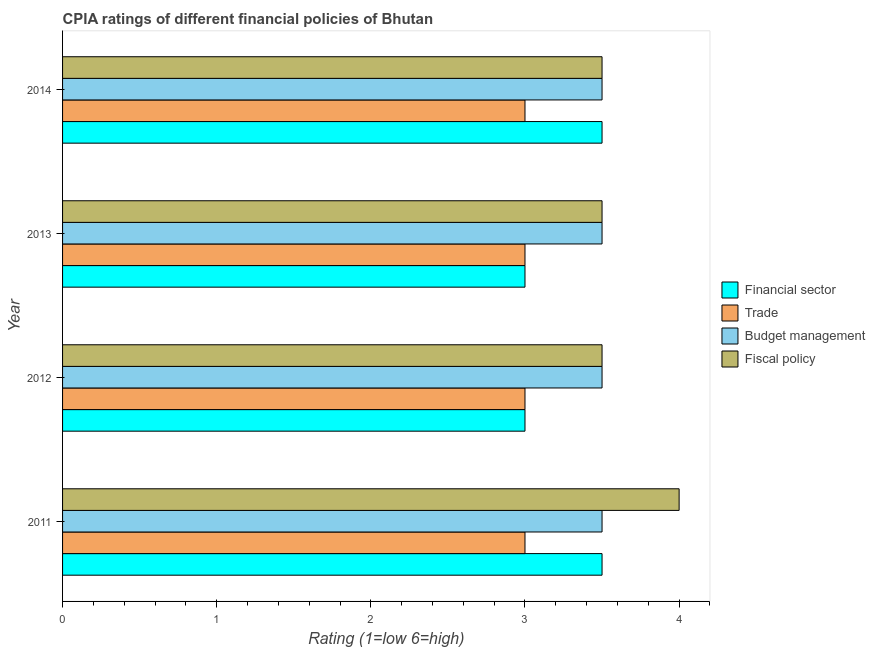How many different coloured bars are there?
Keep it short and to the point. 4. Are the number of bars per tick equal to the number of legend labels?
Your response must be concise. Yes. Are the number of bars on each tick of the Y-axis equal?
Offer a very short reply. Yes. How many bars are there on the 4th tick from the top?
Your answer should be compact. 4. In how many cases, is the number of bars for a given year not equal to the number of legend labels?
Your response must be concise. 0. What is the cpia rating of financial sector in 2012?
Your response must be concise. 3. Across all years, what is the maximum cpia rating of trade?
Provide a short and direct response. 3. Across all years, what is the minimum cpia rating of budget management?
Keep it short and to the point. 3.5. What is the total cpia rating of trade in the graph?
Your answer should be very brief. 12. What is the difference between the cpia rating of trade in 2011 and that in 2012?
Offer a very short reply. 0. What is the average cpia rating of trade per year?
Offer a very short reply. 3. What is the ratio of the cpia rating of financial sector in 2011 to that in 2012?
Offer a terse response. 1.17. What is the difference between the highest and the second highest cpia rating of financial sector?
Your response must be concise. 0. In how many years, is the cpia rating of trade greater than the average cpia rating of trade taken over all years?
Give a very brief answer. 0. Is the sum of the cpia rating of financial sector in 2011 and 2012 greater than the maximum cpia rating of fiscal policy across all years?
Provide a succinct answer. Yes. Is it the case that in every year, the sum of the cpia rating of financial sector and cpia rating of trade is greater than the sum of cpia rating of fiscal policy and cpia rating of budget management?
Give a very brief answer. No. What does the 2nd bar from the top in 2013 represents?
Your answer should be compact. Budget management. What does the 4th bar from the bottom in 2013 represents?
Ensure brevity in your answer.  Fiscal policy. How many bars are there?
Your answer should be very brief. 16. Are all the bars in the graph horizontal?
Provide a succinct answer. Yes. What is the difference between two consecutive major ticks on the X-axis?
Offer a very short reply. 1. Does the graph contain grids?
Offer a very short reply. No. Where does the legend appear in the graph?
Your answer should be compact. Center right. How many legend labels are there?
Provide a short and direct response. 4. What is the title of the graph?
Keep it short and to the point. CPIA ratings of different financial policies of Bhutan. What is the label or title of the Y-axis?
Your response must be concise. Year. What is the Rating (1=low 6=high) of Financial sector in 2011?
Give a very brief answer. 3.5. What is the Rating (1=low 6=high) in Trade in 2012?
Ensure brevity in your answer.  3. What is the Rating (1=low 6=high) of Fiscal policy in 2012?
Your answer should be very brief. 3.5. What is the Rating (1=low 6=high) of Financial sector in 2013?
Offer a terse response. 3. What is the Rating (1=low 6=high) in Trade in 2013?
Ensure brevity in your answer.  3. What is the Rating (1=low 6=high) in Fiscal policy in 2013?
Give a very brief answer. 3.5. What is the Rating (1=low 6=high) of Financial sector in 2014?
Your answer should be very brief. 3.5. What is the Rating (1=low 6=high) of Trade in 2014?
Ensure brevity in your answer.  3. What is the Rating (1=low 6=high) in Budget management in 2014?
Your answer should be compact. 3.5. What is the Rating (1=low 6=high) in Fiscal policy in 2014?
Keep it short and to the point. 3.5. Across all years, what is the maximum Rating (1=low 6=high) of Fiscal policy?
Offer a terse response. 4. What is the total Rating (1=low 6=high) in Financial sector in the graph?
Offer a terse response. 13. What is the total Rating (1=low 6=high) in Budget management in the graph?
Your answer should be very brief. 14. What is the total Rating (1=low 6=high) in Fiscal policy in the graph?
Ensure brevity in your answer.  14.5. What is the difference between the Rating (1=low 6=high) of Budget management in 2011 and that in 2012?
Provide a succinct answer. 0. What is the difference between the Rating (1=low 6=high) of Trade in 2011 and that in 2013?
Offer a terse response. 0. What is the difference between the Rating (1=low 6=high) in Budget management in 2011 and that in 2013?
Keep it short and to the point. 0. What is the difference between the Rating (1=low 6=high) in Fiscal policy in 2011 and that in 2013?
Ensure brevity in your answer.  0.5. What is the difference between the Rating (1=low 6=high) of Financial sector in 2011 and that in 2014?
Your answer should be compact. 0. What is the difference between the Rating (1=low 6=high) in Trade in 2011 and that in 2014?
Offer a very short reply. 0. What is the difference between the Rating (1=low 6=high) in Budget management in 2011 and that in 2014?
Provide a succinct answer. 0. What is the difference between the Rating (1=low 6=high) in Financial sector in 2012 and that in 2013?
Your answer should be compact. 0. What is the difference between the Rating (1=low 6=high) in Budget management in 2012 and that in 2013?
Make the answer very short. 0. What is the difference between the Rating (1=low 6=high) of Fiscal policy in 2012 and that in 2013?
Your answer should be very brief. 0. What is the difference between the Rating (1=low 6=high) in Trade in 2012 and that in 2014?
Your answer should be compact. 0. What is the difference between the Rating (1=low 6=high) in Budget management in 2012 and that in 2014?
Your answer should be very brief. 0. What is the difference between the Rating (1=low 6=high) of Trade in 2013 and that in 2014?
Your answer should be very brief. 0. What is the difference between the Rating (1=low 6=high) in Budget management in 2013 and that in 2014?
Your response must be concise. 0. What is the difference between the Rating (1=low 6=high) in Financial sector in 2011 and the Rating (1=low 6=high) in Trade in 2012?
Give a very brief answer. 0.5. What is the difference between the Rating (1=low 6=high) of Trade in 2011 and the Rating (1=low 6=high) of Budget management in 2012?
Ensure brevity in your answer.  -0.5. What is the difference between the Rating (1=low 6=high) of Budget management in 2011 and the Rating (1=low 6=high) of Fiscal policy in 2012?
Your answer should be compact. 0. What is the difference between the Rating (1=low 6=high) of Financial sector in 2011 and the Rating (1=low 6=high) of Budget management in 2013?
Provide a short and direct response. 0. What is the difference between the Rating (1=low 6=high) of Financial sector in 2011 and the Rating (1=low 6=high) of Fiscal policy in 2013?
Keep it short and to the point. 0. What is the difference between the Rating (1=low 6=high) of Trade in 2011 and the Rating (1=low 6=high) of Budget management in 2013?
Make the answer very short. -0.5. What is the difference between the Rating (1=low 6=high) in Budget management in 2011 and the Rating (1=low 6=high) in Fiscal policy in 2013?
Offer a terse response. 0. What is the difference between the Rating (1=low 6=high) of Financial sector in 2011 and the Rating (1=low 6=high) of Fiscal policy in 2014?
Give a very brief answer. 0. What is the difference between the Rating (1=low 6=high) in Trade in 2011 and the Rating (1=low 6=high) in Budget management in 2014?
Offer a very short reply. -0.5. What is the difference between the Rating (1=low 6=high) of Trade in 2011 and the Rating (1=low 6=high) of Fiscal policy in 2014?
Provide a succinct answer. -0.5. What is the difference between the Rating (1=low 6=high) of Budget management in 2011 and the Rating (1=low 6=high) of Fiscal policy in 2014?
Provide a succinct answer. 0. What is the difference between the Rating (1=low 6=high) of Financial sector in 2012 and the Rating (1=low 6=high) of Fiscal policy in 2013?
Offer a very short reply. -0.5. What is the difference between the Rating (1=low 6=high) of Trade in 2012 and the Rating (1=low 6=high) of Budget management in 2013?
Provide a succinct answer. -0.5. What is the difference between the Rating (1=low 6=high) in Trade in 2012 and the Rating (1=low 6=high) in Fiscal policy in 2013?
Provide a short and direct response. -0.5. What is the difference between the Rating (1=low 6=high) in Financial sector in 2012 and the Rating (1=low 6=high) in Trade in 2014?
Offer a terse response. 0. What is the difference between the Rating (1=low 6=high) in Trade in 2012 and the Rating (1=low 6=high) in Fiscal policy in 2014?
Your response must be concise. -0.5. What is the difference between the Rating (1=low 6=high) of Financial sector in 2013 and the Rating (1=low 6=high) of Fiscal policy in 2014?
Offer a terse response. -0.5. What is the difference between the Rating (1=low 6=high) of Trade in 2013 and the Rating (1=low 6=high) of Budget management in 2014?
Your answer should be compact. -0.5. What is the average Rating (1=low 6=high) in Trade per year?
Provide a succinct answer. 3. What is the average Rating (1=low 6=high) in Fiscal policy per year?
Give a very brief answer. 3.62. In the year 2011, what is the difference between the Rating (1=low 6=high) of Financial sector and Rating (1=low 6=high) of Fiscal policy?
Your response must be concise. -0.5. In the year 2011, what is the difference between the Rating (1=low 6=high) in Trade and Rating (1=low 6=high) in Budget management?
Keep it short and to the point. -0.5. In the year 2011, what is the difference between the Rating (1=low 6=high) in Budget management and Rating (1=low 6=high) in Fiscal policy?
Make the answer very short. -0.5. In the year 2012, what is the difference between the Rating (1=low 6=high) of Financial sector and Rating (1=low 6=high) of Fiscal policy?
Provide a succinct answer. -0.5. In the year 2012, what is the difference between the Rating (1=low 6=high) in Trade and Rating (1=low 6=high) in Budget management?
Give a very brief answer. -0.5. In the year 2012, what is the difference between the Rating (1=low 6=high) in Budget management and Rating (1=low 6=high) in Fiscal policy?
Your answer should be very brief. 0. In the year 2013, what is the difference between the Rating (1=low 6=high) of Financial sector and Rating (1=low 6=high) of Trade?
Make the answer very short. 0. In the year 2013, what is the difference between the Rating (1=low 6=high) in Trade and Rating (1=low 6=high) in Fiscal policy?
Offer a very short reply. -0.5. In the year 2013, what is the difference between the Rating (1=low 6=high) of Budget management and Rating (1=low 6=high) of Fiscal policy?
Offer a terse response. 0. In the year 2014, what is the difference between the Rating (1=low 6=high) in Financial sector and Rating (1=low 6=high) in Budget management?
Your response must be concise. 0. In the year 2014, what is the difference between the Rating (1=low 6=high) in Trade and Rating (1=low 6=high) in Budget management?
Your response must be concise. -0.5. What is the ratio of the Rating (1=low 6=high) of Trade in 2011 to that in 2012?
Provide a short and direct response. 1. What is the ratio of the Rating (1=low 6=high) in Budget management in 2011 to that in 2013?
Provide a short and direct response. 1. What is the ratio of the Rating (1=low 6=high) of Fiscal policy in 2011 to that in 2013?
Your answer should be very brief. 1.14. What is the ratio of the Rating (1=low 6=high) in Financial sector in 2011 to that in 2014?
Keep it short and to the point. 1. What is the ratio of the Rating (1=low 6=high) of Trade in 2011 to that in 2014?
Your answer should be very brief. 1. What is the ratio of the Rating (1=low 6=high) of Financial sector in 2012 to that in 2013?
Offer a very short reply. 1. What is the ratio of the Rating (1=low 6=high) in Trade in 2012 to that in 2013?
Give a very brief answer. 1. What is the ratio of the Rating (1=low 6=high) in Trade in 2012 to that in 2014?
Provide a short and direct response. 1. What is the ratio of the Rating (1=low 6=high) in Budget management in 2012 to that in 2014?
Keep it short and to the point. 1. What is the ratio of the Rating (1=low 6=high) of Financial sector in 2013 to that in 2014?
Keep it short and to the point. 0.86. What is the ratio of the Rating (1=low 6=high) in Budget management in 2013 to that in 2014?
Your response must be concise. 1. What is the difference between the highest and the second highest Rating (1=low 6=high) in Financial sector?
Provide a succinct answer. 0. What is the difference between the highest and the lowest Rating (1=low 6=high) of Budget management?
Offer a terse response. 0. 